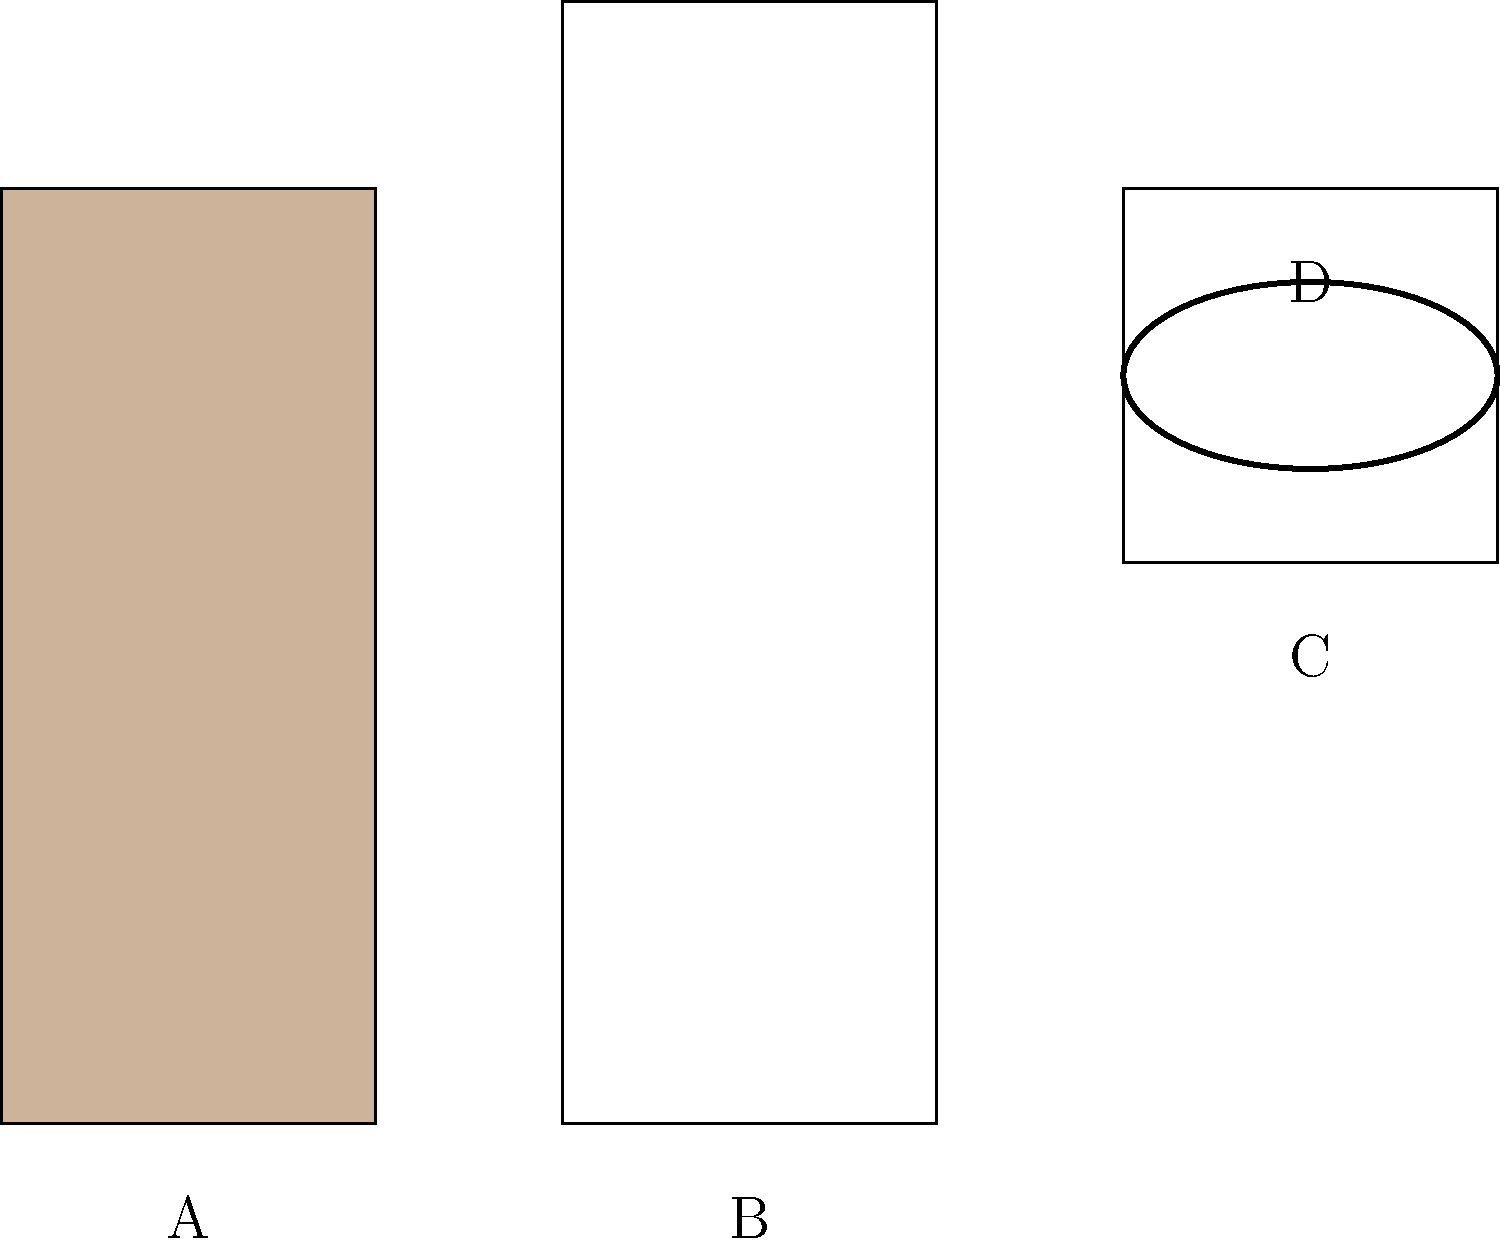Identify the traditional Arab clothing item that is typically worn as a long, loose-fitting robe and is common in many Arab countries, including among some Arab Christians. Which letter corresponds to this item? Let's analyze each item in the image:

1. Item A: This appears to be a bisht or abaya, which is a cloak-like outer garment worn over other clothes.

2. Item B: This is a thobe (also known as dishdasha or kandura), a long, loose-fitting robe that reaches the ankles. It is the most common traditional clothing for men in many Arab countries and is worn by both Muslims and Christians.

3. Item C: This is a keffiyeh (also spelled kufiya), a traditional Middle Eastern headdress worn by men.

4. Item D: This circular item on top of the keffiyeh is an agal, a rope-like accessory used to keep the keffiyeh in place.

The question asks for the long, loose-fitting robe common in Arab countries. This description best matches item B, the thobe. While thobes are often associated with Muslim attire, they are also worn by Arab Christians in many countries as traditional cultural clothing.
Answer: B 